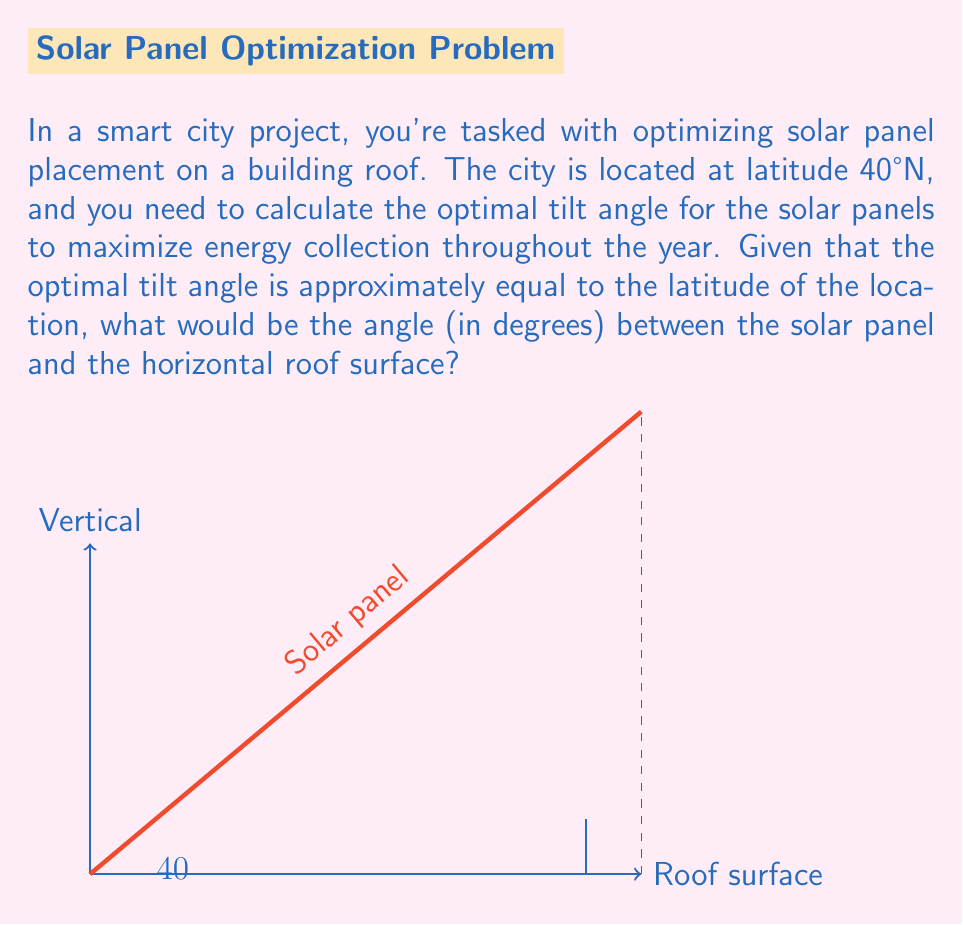Teach me how to tackle this problem. To solve this problem, we'll follow these steps:

1) First, recall that the optimal tilt angle for solar panels is approximately equal to the latitude of the location. In this case, the city is located at 40°N latitude.

2) The question asks for the angle between the solar panel and the horizontal roof surface. This is the same as the optimal tilt angle.

3) Therefore, the optimal tilt angle for the solar panels is:

   $\text{Optimal Tilt Angle} = \text{Latitude} = 40°$

4) We can verify this using the following reasoning:
   - At 40°N, the sun's highest point in the sky during the summer solstice is about 73.5° above the horizon (90° - 40° + 23.5°, where 23.5° is the Earth's axial tilt).
   - During the winter solstice, the sun's highest point is about 26.5° above the horizon (90° - 40° - 23.5°).
   - A tilt angle of 40° is a good compromise to capture optimal sunlight throughout the year.

5) In the smart city context, this angle allows for:
   - Efficient energy collection throughout the year
   - Easy integration with smart grid systems for optimal energy distribution
   - Potential for automated cleaning and maintenance systems to operate effectively

Thus, the angle between the solar panel and the horizontal roof surface should be 40°.
Answer: $40°$ 